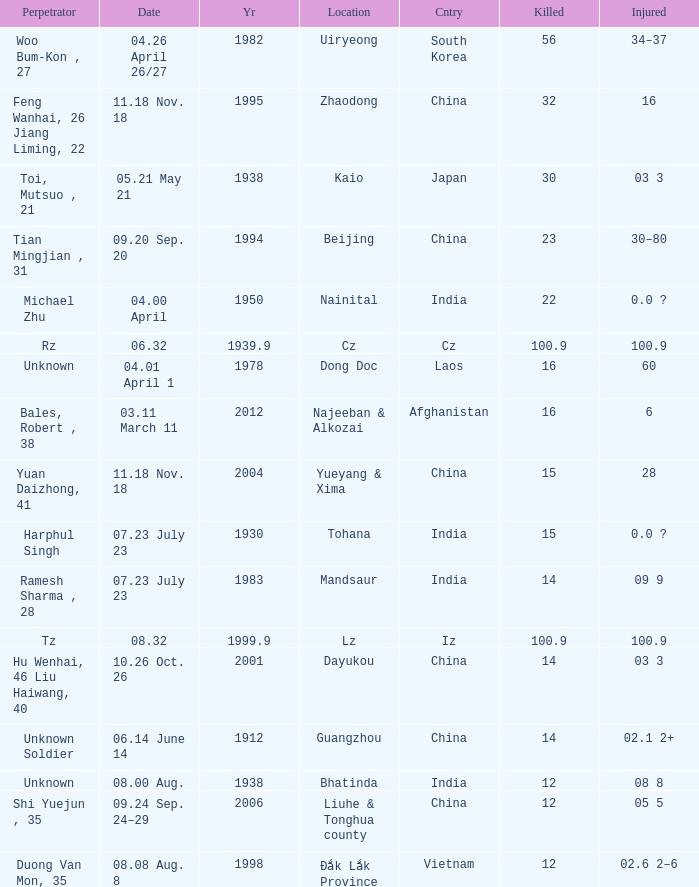What is the average Year, when Date is "04.01 April 1"? 1978.0. 